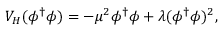Convert formula to latex. <formula><loc_0><loc_0><loc_500><loc_500>V _ { H } ( \phi ^ { \dagger } \phi ) = - \mu ^ { 2 } \phi ^ { \dagger } \phi + \lambda ( \phi ^ { \dagger } \phi ) ^ { 2 } ,</formula> 